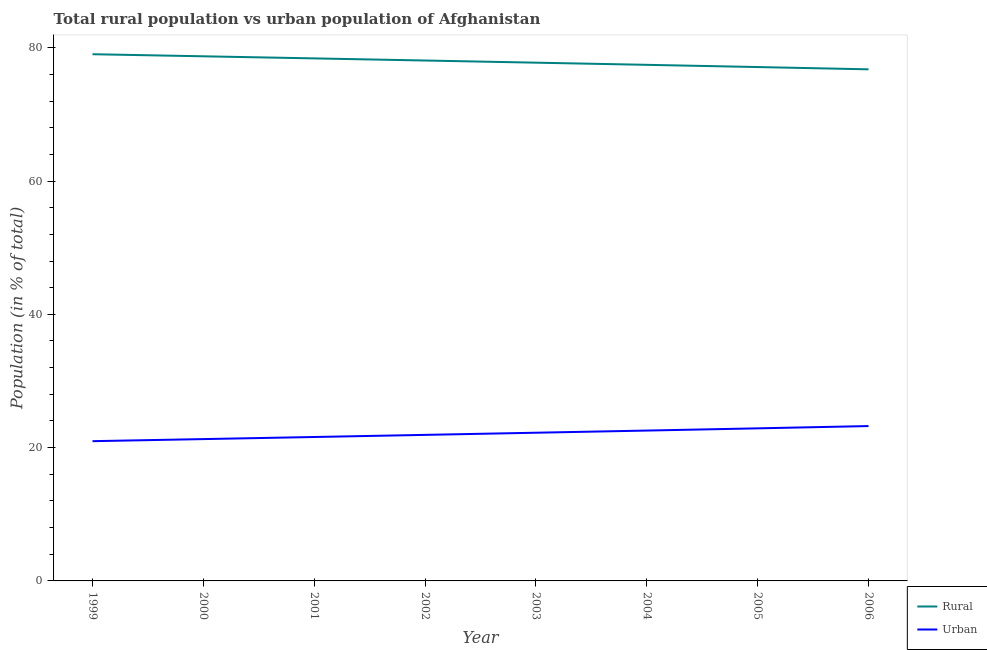How many different coloured lines are there?
Make the answer very short. 2. Does the line corresponding to urban population intersect with the line corresponding to rural population?
Make the answer very short. No. What is the rural population in 2001?
Make the answer very short. 78.4. Across all years, what is the maximum urban population?
Your response must be concise. 23.24. Across all years, what is the minimum urban population?
Provide a succinct answer. 20.97. What is the total urban population in the graph?
Your answer should be compact. 176.69. What is the difference between the rural population in 2000 and that in 2002?
Your answer should be compact. 0.63. What is the difference between the rural population in 2002 and the urban population in 2001?
Offer a terse response. 56.49. What is the average rural population per year?
Offer a very short reply. 77.91. In the year 1999, what is the difference between the rural population and urban population?
Make the answer very short. 58.06. In how many years, is the urban population greater than 72 %?
Provide a short and direct response. 0. What is the ratio of the rural population in 2001 to that in 2006?
Give a very brief answer. 1.02. Is the rural population in 2001 less than that in 2006?
Provide a short and direct response. No. What is the difference between the highest and the second highest rural population?
Provide a succinct answer. 0.31. What is the difference between the highest and the lowest urban population?
Give a very brief answer. 2.27. In how many years, is the rural population greater than the average rural population taken over all years?
Provide a short and direct response. 4. Is the sum of the urban population in 1999 and 2003 greater than the maximum rural population across all years?
Provide a succinct answer. No. Is the rural population strictly greater than the urban population over the years?
Make the answer very short. Yes. Is the urban population strictly less than the rural population over the years?
Give a very brief answer. Yes. How many years are there in the graph?
Keep it short and to the point. 8. What is the difference between two consecutive major ticks on the Y-axis?
Give a very brief answer. 20. Are the values on the major ticks of Y-axis written in scientific E-notation?
Your answer should be compact. No. Does the graph contain grids?
Make the answer very short. No. Where does the legend appear in the graph?
Offer a very short reply. Bottom right. How many legend labels are there?
Make the answer very short. 2. What is the title of the graph?
Your answer should be very brief. Total rural population vs urban population of Afghanistan. What is the label or title of the X-axis?
Provide a succinct answer. Year. What is the label or title of the Y-axis?
Your response must be concise. Population (in % of total). What is the Population (in % of total) of Rural in 1999?
Keep it short and to the point. 79.03. What is the Population (in % of total) of Urban in 1999?
Make the answer very short. 20.97. What is the Population (in % of total) in Rural in 2000?
Provide a short and direct response. 78.72. What is the Population (in % of total) in Urban in 2000?
Offer a terse response. 21.28. What is the Population (in % of total) in Rural in 2001?
Offer a very short reply. 78.4. What is the Population (in % of total) in Urban in 2001?
Provide a succinct answer. 21.6. What is the Population (in % of total) of Rural in 2002?
Provide a short and direct response. 78.08. What is the Population (in % of total) in Urban in 2002?
Your response must be concise. 21.91. What is the Population (in % of total) in Rural in 2003?
Offer a terse response. 77.76. What is the Population (in % of total) in Urban in 2003?
Offer a very short reply. 22.24. What is the Population (in % of total) of Rural in 2004?
Provide a succinct answer. 77.44. What is the Population (in % of total) of Urban in 2004?
Offer a very short reply. 22.56. What is the Population (in % of total) in Rural in 2005?
Provide a short and direct response. 77.11. What is the Population (in % of total) in Urban in 2005?
Offer a terse response. 22.89. What is the Population (in % of total) of Rural in 2006?
Make the answer very short. 76.76. What is the Population (in % of total) in Urban in 2006?
Offer a very short reply. 23.24. Across all years, what is the maximum Population (in % of total) of Rural?
Offer a very short reply. 79.03. Across all years, what is the maximum Population (in % of total) of Urban?
Your answer should be very brief. 23.24. Across all years, what is the minimum Population (in % of total) of Rural?
Your answer should be compact. 76.76. Across all years, what is the minimum Population (in % of total) of Urban?
Give a very brief answer. 20.97. What is the total Population (in % of total) of Rural in the graph?
Provide a short and direct response. 623.31. What is the total Population (in % of total) of Urban in the graph?
Offer a terse response. 176.69. What is the difference between the Population (in % of total) in Rural in 1999 and that in 2000?
Your response must be concise. 0.31. What is the difference between the Population (in % of total) of Urban in 1999 and that in 2000?
Provide a short and direct response. -0.31. What is the difference between the Population (in % of total) of Rural in 1999 and that in 2001?
Keep it short and to the point. 0.63. What is the difference between the Population (in % of total) in Urban in 1999 and that in 2001?
Make the answer very short. -0.63. What is the difference between the Population (in % of total) of Rural in 1999 and that in 2002?
Your answer should be compact. 0.94. What is the difference between the Population (in % of total) in Urban in 1999 and that in 2002?
Provide a short and direct response. -0.94. What is the difference between the Population (in % of total) of Rural in 1999 and that in 2003?
Keep it short and to the point. 1.27. What is the difference between the Population (in % of total) in Urban in 1999 and that in 2003?
Offer a terse response. -1.27. What is the difference between the Population (in % of total) of Rural in 1999 and that in 2004?
Offer a very short reply. 1.59. What is the difference between the Population (in % of total) in Urban in 1999 and that in 2004?
Your answer should be compact. -1.59. What is the difference between the Population (in % of total) in Rural in 1999 and that in 2005?
Keep it short and to the point. 1.93. What is the difference between the Population (in % of total) in Urban in 1999 and that in 2005?
Give a very brief answer. -1.93. What is the difference between the Population (in % of total) in Rural in 1999 and that in 2006?
Make the answer very short. 2.27. What is the difference between the Population (in % of total) in Urban in 1999 and that in 2006?
Your answer should be compact. -2.27. What is the difference between the Population (in % of total) in Rural in 2000 and that in 2001?
Make the answer very short. 0.31. What is the difference between the Population (in % of total) of Urban in 2000 and that in 2001?
Give a very brief answer. -0.31. What is the difference between the Population (in % of total) of Rural in 2000 and that in 2002?
Provide a short and direct response. 0.63. What is the difference between the Population (in % of total) in Urban in 2000 and that in 2002?
Your answer should be very brief. -0.63. What is the difference between the Population (in % of total) in Rural in 2000 and that in 2003?
Your response must be concise. 0.95. What is the difference between the Population (in % of total) of Urban in 2000 and that in 2003?
Make the answer very short. -0.95. What is the difference between the Population (in % of total) in Rural in 2000 and that in 2004?
Make the answer very short. 1.28. What is the difference between the Population (in % of total) of Urban in 2000 and that in 2004?
Offer a terse response. -1.28. What is the difference between the Population (in % of total) in Rural in 2000 and that in 2005?
Give a very brief answer. 1.61. What is the difference between the Population (in % of total) of Urban in 2000 and that in 2005?
Your answer should be compact. -1.61. What is the difference between the Population (in % of total) in Rural in 2000 and that in 2006?
Keep it short and to the point. 1.96. What is the difference between the Population (in % of total) of Urban in 2000 and that in 2006?
Your response must be concise. -1.96. What is the difference between the Population (in % of total) of Rural in 2001 and that in 2002?
Provide a short and direct response. 0.32. What is the difference between the Population (in % of total) of Urban in 2001 and that in 2002?
Provide a short and direct response. -0.32. What is the difference between the Population (in % of total) in Rural in 2001 and that in 2003?
Ensure brevity in your answer.  0.64. What is the difference between the Population (in % of total) in Urban in 2001 and that in 2003?
Provide a short and direct response. -0.64. What is the difference between the Population (in % of total) of Rural in 2001 and that in 2004?
Keep it short and to the point. 0.97. What is the difference between the Population (in % of total) of Urban in 2001 and that in 2004?
Provide a short and direct response. -0.97. What is the difference between the Population (in % of total) of Rural in 2001 and that in 2005?
Ensure brevity in your answer.  1.3. What is the difference between the Population (in % of total) in Urban in 2001 and that in 2005?
Make the answer very short. -1.3. What is the difference between the Population (in % of total) of Rural in 2001 and that in 2006?
Your answer should be compact. 1.64. What is the difference between the Population (in % of total) of Urban in 2001 and that in 2006?
Offer a terse response. -1.64. What is the difference between the Population (in % of total) in Rural in 2002 and that in 2003?
Your response must be concise. 0.32. What is the difference between the Population (in % of total) in Urban in 2002 and that in 2003?
Give a very brief answer. -0.32. What is the difference between the Population (in % of total) in Rural in 2002 and that in 2004?
Your answer should be very brief. 0.65. What is the difference between the Population (in % of total) in Urban in 2002 and that in 2004?
Provide a succinct answer. -0.65. What is the difference between the Population (in % of total) in Urban in 2002 and that in 2005?
Offer a very short reply. -0.98. What is the difference between the Population (in % of total) of Rural in 2002 and that in 2006?
Your response must be concise. 1.32. What is the difference between the Population (in % of total) of Urban in 2002 and that in 2006?
Offer a very short reply. -1.32. What is the difference between the Population (in % of total) of Rural in 2003 and that in 2004?
Provide a succinct answer. 0.33. What is the difference between the Population (in % of total) in Urban in 2003 and that in 2004?
Your answer should be very brief. -0.33. What is the difference between the Population (in % of total) of Rural in 2003 and that in 2005?
Ensure brevity in your answer.  0.66. What is the difference between the Population (in % of total) of Urban in 2003 and that in 2005?
Ensure brevity in your answer.  -0.66. What is the difference between the Population (in % of total) of Rural in 2003 and that in 2006?
Make the answer very short. 1. What is the difference between the Population (in % of total) of Rural in 2004 and that in 2005?
Your answer should be very brief. 0.33. What is the difference between the Population (in % of total) of Urban in 2004 and that in 2005?
Ensure brevity in your answer.  -0.33. What is the difference between the Population (in % of total) of Rural in 2004 and that in 2006?
Keep it short and to the point. 0.68. What is the difference between the Population (in % of total) in Urban in 2004 and that in 2006?
Offer a terse response. -0.68. What is the difference between the Population (in % of total) of Rural in 2005 and that in 2006?
Ensure brevity in your answer.  0.34. What is the difference between the Population (in % of total) of Urban in 2005 and that in 2006?
Provide a succinct answer. -0.34. What is the difference between the Population (in % of total) in Rural in 1999 and the Population (in % of total) in Urban in 2000?
Your answer should be compact. 57.75. What is the difference between the Population (in % of total) in Rural in 1999 and the Population (in % of total) in Urban in 2001?
Ensure brevity in your answer.  57.43. What is the difference between the Population (in % of total) in Rural in 1999 and the Population (in % of total) in Urban in 2002?
Your response must be concise. 57.12. What is the difference between the Population (in % of total) in Rural in 1999 and the Population (in % of total) in Urban in 2003?
Offer a terse response. 56.79. What is the difference between the Population (in % of total) in Rural in 1999 and the Population (in % of total) in Urban in 2004?
Your answer should be very brief. 56.47. What is the difference between the Population (in % of total) of Rural in 1999 and the Population (in % of total) of Urban in 2005?
Your answer should be very brief. 56.13. What is the difference between the Population (in % of total) in Rural in 1999 and the Population (in % of total) in Urban in 2006?
Your response must be concise. 55.79. What is the difference between the Population (in % of total) in Rural in 2000 and the Population (in % of total) in Urban in 2001?
Your answer should be very brief. 57.12. What is the difference between the Population (in % of total) of Rural in 2000 and the Population (in % of total) of Urban in 2002?
Offer a terse response. 56.8. What is the difference between the Population (in % of total) in Rural in 2000 and the Population (in % of total) in Urban in 2003?
Provide a short and direct response. 56.48. What is the difference between the Population (in % of total) in Rural in 2000 and the Population (in % of total) in Urban in 2004?
Give a very brief answer. 56.16. What is the difference between the Population (in % of total) in Rural in 2000 and the Population (in % of total) in Urban in 2005?
Your response must be concise. 55.82. What is the difference between the Population (in % of total) in Rural in 2000 and the Population (in % of total) in Urban in 2006?
Keep it short and to the point. 55.48. What is the difference between the Population (in % of total) in Rural in 2001 and the Population (in % of total) in Urban in 2002?
Offer a terse response. 56.49. What is the difference between the Population (in % of total) in Rural in 2001 and the Population (in % of total) in Urban in 2003?
Offer a very short reply. 56.17. What is the difference between the Population (in % of total) in Rural in 2001 and the Population (in % of total) in Urban in 2004?
Your answer should be very brief. 55.84. What is the difference between the Population (in % of total) of Rural in 2001 and the Population (in % of total) of Urban in 2005?
Ensure brevity in your answer.  55.51. What is the difference between the Population (in % of total) of Rural in 2001 and the Population (in % of total) of Urban in 2006?
Your response must be concise. 55.17. What is the difference between the Population (in % of total) of Rural in 2002 and the Population (in % of total) of Urban in 2003?
Give a very brief answer. 55.85. What is the difference between the Population (in % of total) in Rural in 2002 and the Population (in % of total) in Urban in 2004?
Offer a terse response. 55.52. What is the difference between the Population (in % of total) of Rural in 2002 and the Population (in % of total) of Urban in 2005?
Provide a short and direct response. 55.19. What is the difference between the Population (in % of total) of Rural in 2002 and the Population (in % of total) of Urban in 2006?
Keep it short and to the point. 54.85. What is the difference between the Population (in % of total) in Rural in 2003 and the Population (in % of total) in Urban in 2004?
Your answer should be very brief. 55.2. What is the difference between the Population (in % of total) of Rural in 2003 and the Population (in % of total) of Urban in 2005?
Provide a short and direct response. 54.87. What is the difference between the Population (in % of total) of Rural in 2003 and the Population (in % of total) of Urban in 2006?
Offer a terse response. 54.53. What is the difference between the Population (in % of total) in Rural in 2004 and the Population (in % of total) in Urban in 2005?
Provide a succinct answer. 54.54. What is the difference between the Population (in % of total) in Rural in 2004 and the Population (in % of total) in Urban in 2006?
Provide a short and direct response. 54.2. What is the difference between the Population (in % of total) in Rural in 2005 and the Population (in % of total) in Urban in 2006?
Your answer should be very brief. 53.87. What is the average Population (in % of total) in Rural per year?
Provide a succinct answer. 77.91. What is the average Population (in % of total) in Urban per year?
Offer a terse response. 22.09. In the year 1999, what is the difference between the Population (in % of total) of Rural and Population (in % of total) of Urban?
Give a very brief answer. 58.06. In the year 2000, what is the difference between the Population (in % of total) in Rural and Population (in % of total) in Urban?
Give a very brief answer. 57.44. In the year 2001, what is the difference between the Population (in % of total) in Rural and Population (in % of total) in Urban?
Your answer should be compact. 56.81. In the year 2002, what is the difference between the Population (in % of total) in Rural and Population (in % of total) in Urban?
Your response must be concise. 56.17. In the year 2003, what is the difference between the Population (in % of total) of Rural and Population (in % of total) of Urban?
Your response must be concise. 55.53. In the year 2004, what is the difference between the Population (in % of total) of Rural and Population (in % of total) of Urban?
Provide a succinct answer. 54.88. In the year 2005, what is the difference between the Population (in % of total) in Rural and Population (in % of total) in Urban?
Your response must be concise. 54.21. In the year 2006, what is the difference between the Population (in % of total) of Rural and Population (in % of total) of Urban?
Ensure brevity in your answer.  53.53. What is the ratio of the Population (in % of total) of Rural in 1999 to that in 2000?
Offer a terse response. 1. What is the ratio of the Population (in % of total) in Urban in 1999 to that in 2000?
Your answer should be compact. 0.99. What is the ratio of the Population (in % of total) in Rural in 1999 to that in 2001?
Keep it short and to the point. 1.01. What is the ratio of the Population (in % of total) in Rural in 1999 to that in 2002?
Your answer should be very brief. 1.01. What is the ratio of the Population (in % of total) in Urban in 1999 to that in 2002?
Give a very brief answer. 0.96. What is the ratio of the Population (in % of total) of Rural in 1999 to that in 2003?
Your answer should be very brief. 1.02. What is the ratio of the Population (in % of total) in Urban in 1999 to that in 2003?
Your answer should be very brief. 0.94. What is the ratio of the Population (in % of total) of Rural in 1999 to that in 2004?
Your response must be concise. 1.02. What is the ratio of the Population (in % of total) in Urban in 1999 to that in 2004?
Give a very brief answer. 0.93. What is the ratio of the Population (in % of total) of Urban in 1999 to that in 2005?
Your response must be concise. 0.92. What is the ratio of the Population (in % of total) of Rural in 1999 to that in 2006?
Your answer should be very brief. 1.03. What is the ratio of the Population (in % of total) of Urban in 1999 to that in 2006?
Your answer should be compact. 0.9. What is the ratio of the Population (in % of total) of Rural in 2000 to that in 2001?
Your response must be concise. 1. What is the ratio of the Population (in % of total) of Urban in 2000 to that in 2001?
Your answer should be very brief. 0.99. What is the ratio of the Population (in % of total) in Rural in 2000 to that in 2002?
Your answer should be very brief. 1.01. What is the ratio of the Population (in % of total) of Urban in 2000 to that in 2002?
Provide a short and direct response. 0.97. What is the ratio of the Population (in % of total) of Rural in 2000 to that in 2003?
Provide a succinct answer. 1.01. What is the ratio of the Population (in % of total) in Urban in 2000 to that in 2003?
Provide a succinct answer. 0.96. What is the ratio of the Population (in % of total) in Rural in 2000 to that in 2004?
Provide a succinct answer. 1.02. What is the ratio of the Population (in % of total) of Urban in 2000 to that in 2004?
Offer a terse response. 0.94. What is the ratio of the Population (in % of total) in Rural in 2000 to that in 2005?
Your answer should be very brief. 1.02. What is the ratio of the Population (in % of total) of Urban in 2000 to that in 2005?
Provide a succinct answer. 0.93. What is the ratio of the Population (in % of total) of Rural in 2000 to that in 2006?
Ensure brevity in your answer.  1.03. What is the ratio of the Population (in % of total) of Urban in 2000 to that in 2006?
Make the answer very short. 0.92. What is the ratio of the Population (in % of total) in Rural in 2001 to that in 2002?
Provide a short and direct response. 1. What is the ratio of the Population (in % of total) in Urban in 2001 to that in 2002?
Make the answer very short. 0.99. What is the ratio of the Population (in % of total) of Rural in 2001 to that in 2003?
Make the answer very short. 1.01. What is the ratio of the Population (in % of total) of Urban in 2001 to that in 2003?
Offer a terse response. 0.97. What is the ratio of the Population (in % of total) of Rural in 2001 to that in 2004?
Keep it short and to the point. 1.01. What is the ratio of the Population (in % of total) of Urban in 2001 to that in 2004?
Your answer should be very brief. 0.96. What is the ratio of the Population (in % of total) of Rural in 2001 to that in 2005?
Offer a terse response. 1.02. What is the ratio of the Population (in % of total) of Urban in 2001 to that in 2005?
Keep it short and to the point. 0.94. What is the ratio of the Population (in % of total) in Rural in 2001 to that in 2006?
Your answer should be compact. 1.02. What is the ratio of the Population (in % of total) in Urban in 2001 to that in 2006?
Offer a terse response. 0.93. What is the ratio of the Population (in % of total) of Urban in 2002 to that in 2003?
Provide a short and direct response. 0.99. What is the ratio of the Population (in % of total) of Rural in 2002 to that in 2004?
Ensure brevity in your answer.  1.01. What is the ratio of the Population (in % of total) of Urban in 2002 to that in 2004?
Ensure brevity in your answer.  0.97. What is the ratio of the Population (in % of total) in Rural in 2002 to that in 2005?
Your answer should be very brief. 1.01. What is the ratio of the Population (in % of total) in Urban in 2002 to that in 2005?
Make the answer very short. 0.96. What is the ratio of the Population (in % of total) of Rural in 2002 to that in 2006?
Your answer should be very brief. 1.02. What is the ratio of the Population (in % of total) in Urban in 2002 to that in 2006?
Provide a short and direct response. 0.94. What is the ratio of the Population (in % of total) in Urban in 2003 to that in 2004?
Ensure brevity in your answer.  0.99. What is the ratio of the Population (in % of total) of Rural in 2003 to that in 2005?
Give a very brief answer. 1.01. What is the ratio of the Population (in % of total) in Urban in 2003 to that in 2005?
Ensure brevity in your answer.  0.97. What is the ratio of the Population (in % of total) in Urban in 2003 to that in 2006?
Offer a terse response. 0.96. What is the ratio of the Population (in % of total) of Rural in 2004 to that in 2005?
Offer a terse response. 1. What is the ratio of the Population (in % of total) of Urban in 2004 to that in 2005?
Make the answer very short. 0.99. What is the ratio of the Population (in % of total) of Rural in 2004 to that in 2006?
Give a very brief answer. 1.01. What is the ratio of the Population (in % of total) in Urban in 2004 to that in 2006?
Your answer should be compact. 0.97. What is the ratio of the Population (in % of total) of Rural in 2005 to that in 2006?
Make the answer very short. 1. What is the difference between the highest and the second highest Population (in % of total) of Rural?
Give a very brief answer. 0.31. What is the difference between the highest and the second highest Population (in % of total) of Urban?
Your answer should be very brief. 0.34. What is the difference between the highest and the lowest Population (in % of total) in Rural?
Provide a short and direct response. 2.27. What is the difference between the highest and the lowest Population (in % of total) of Urban?
Your response must be concise. 2.27. 